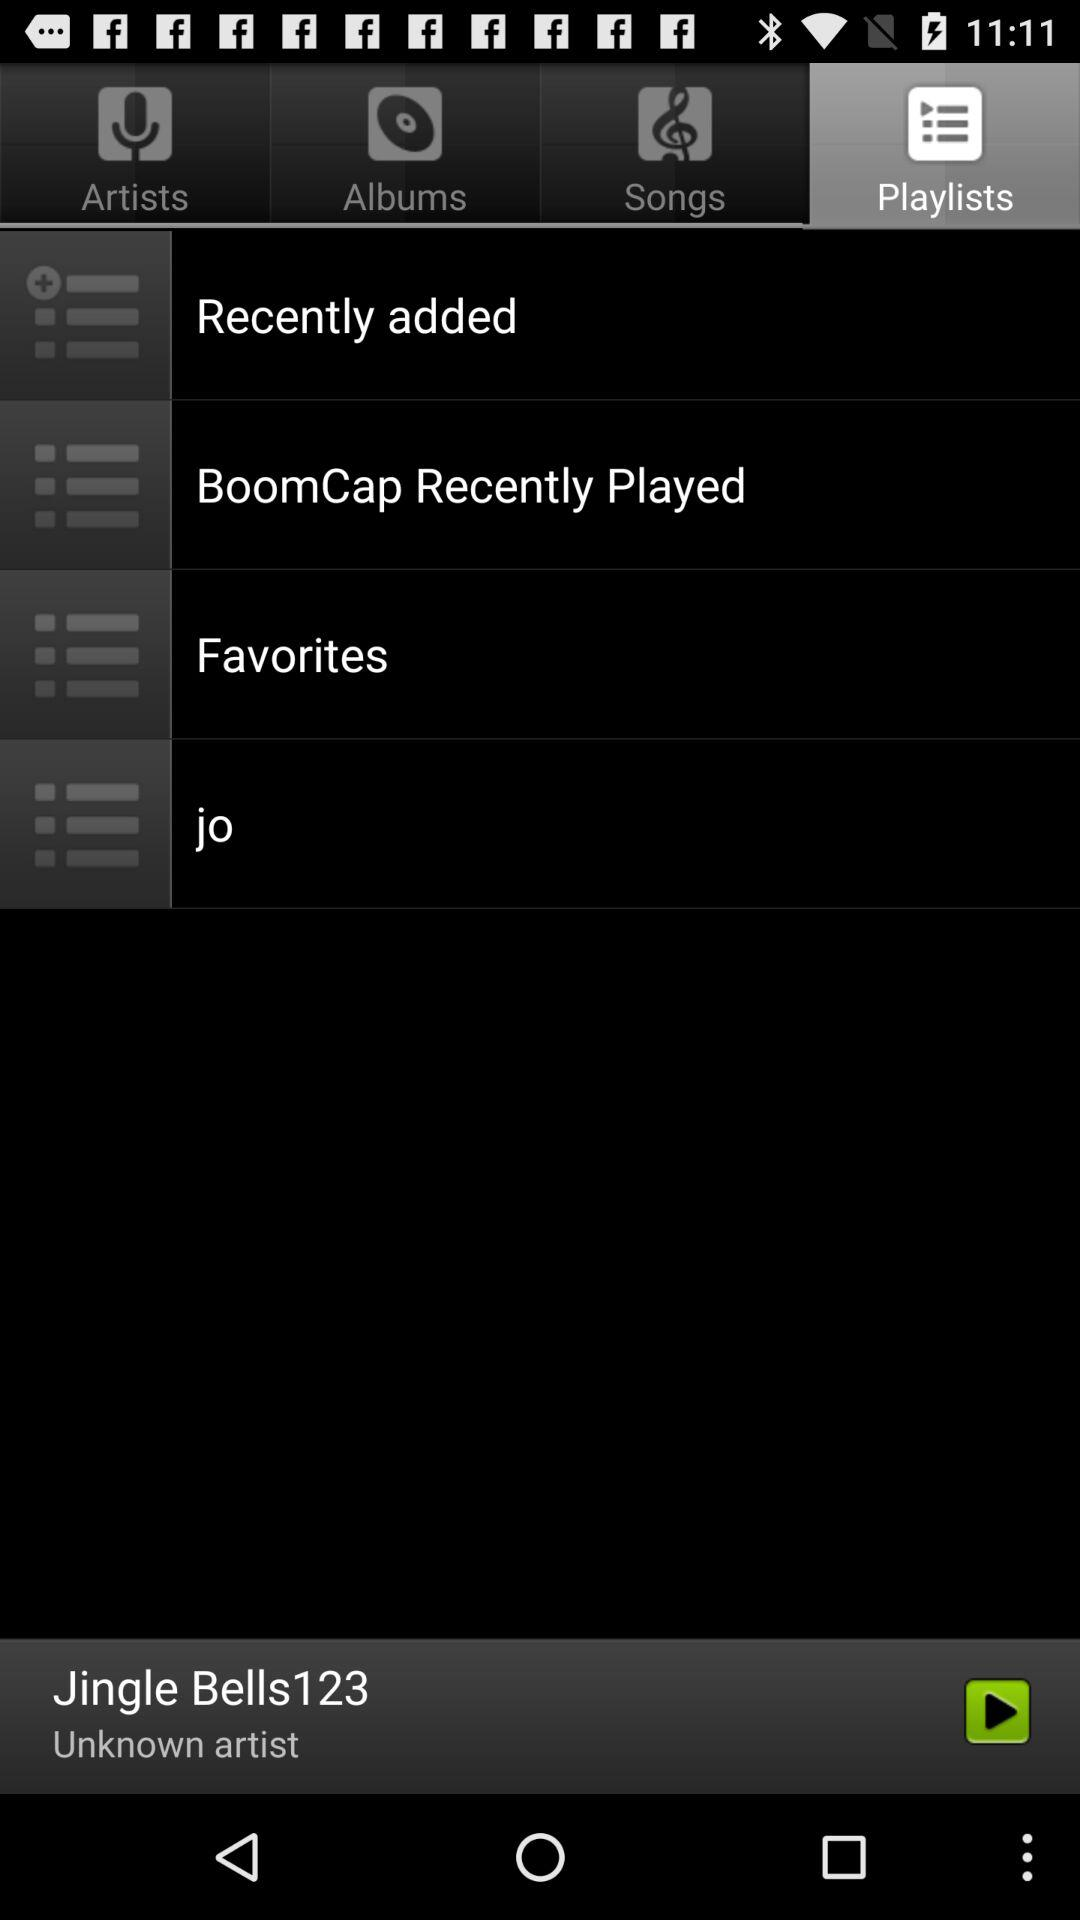Which audio was last played? The last played audio was "Jingle Bells123". 